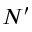<formula> <loc_0><loc_0><loc_500><loc_500>N ^ { \prime }</formula> 